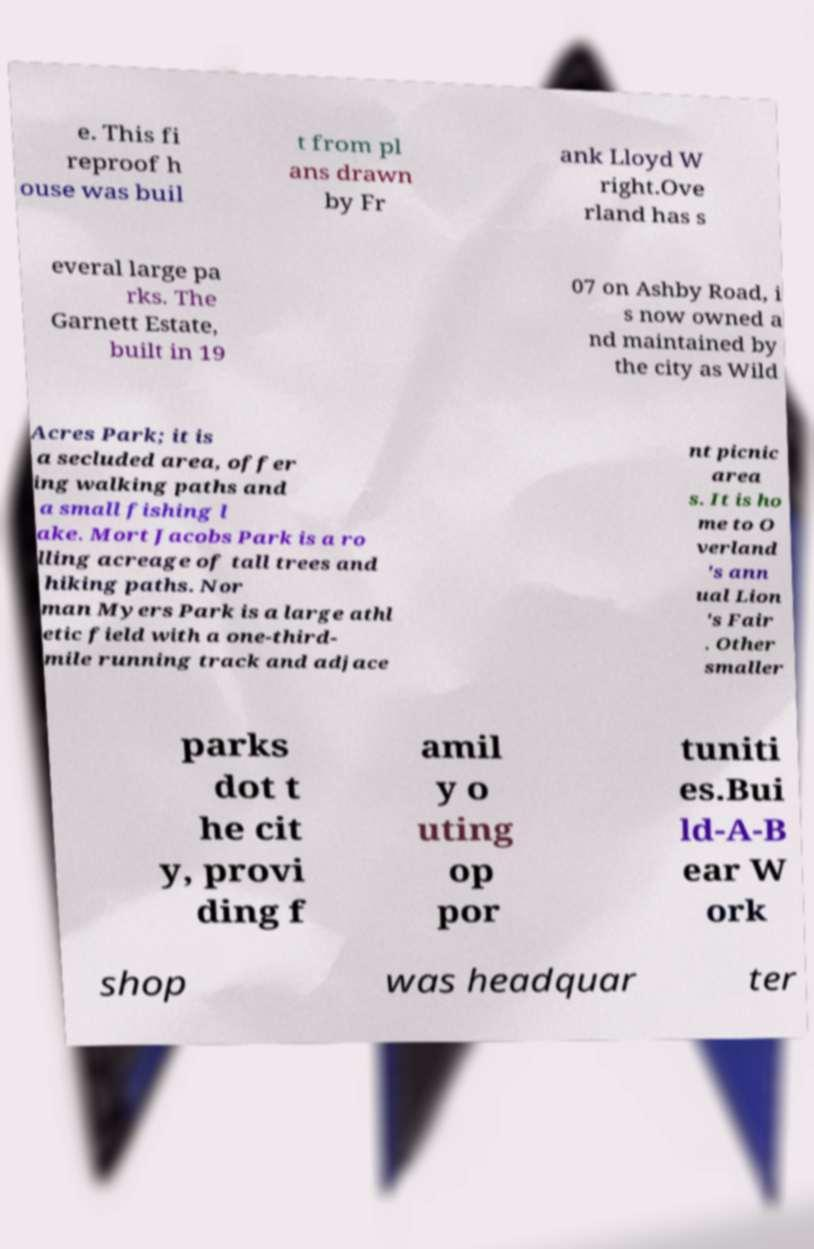Can you read and provide the text displayed in the image?This photo seems to have some interesting text. Can you extract and type it out for me? e. This fi reproof h ouse was buil t from pl ans drawn by Fr ank Lloyd W right.Ove rland has s everal large pa rks. The Garnett Estate, built in 19 07 on Ashby Road, i s now owned a nd maintained by the city as Wild Acres Park; it is a secluded area, offer ing walking paths and a small fishing l ake. Mort Jacobs Park is a ro lling acreage of tall trees and hiking paths. Nor man Myers Park is a large athl etic field with a one-third- mile running track and adjace nt picnic area s. It is ho me to O verland 's ann ual Lion 's Fair . Other smaller parks dot t he cit y, provi ding f amil y o uting op por tuniti es.Bui ld-A-B ear W ork shop was headquar ter 